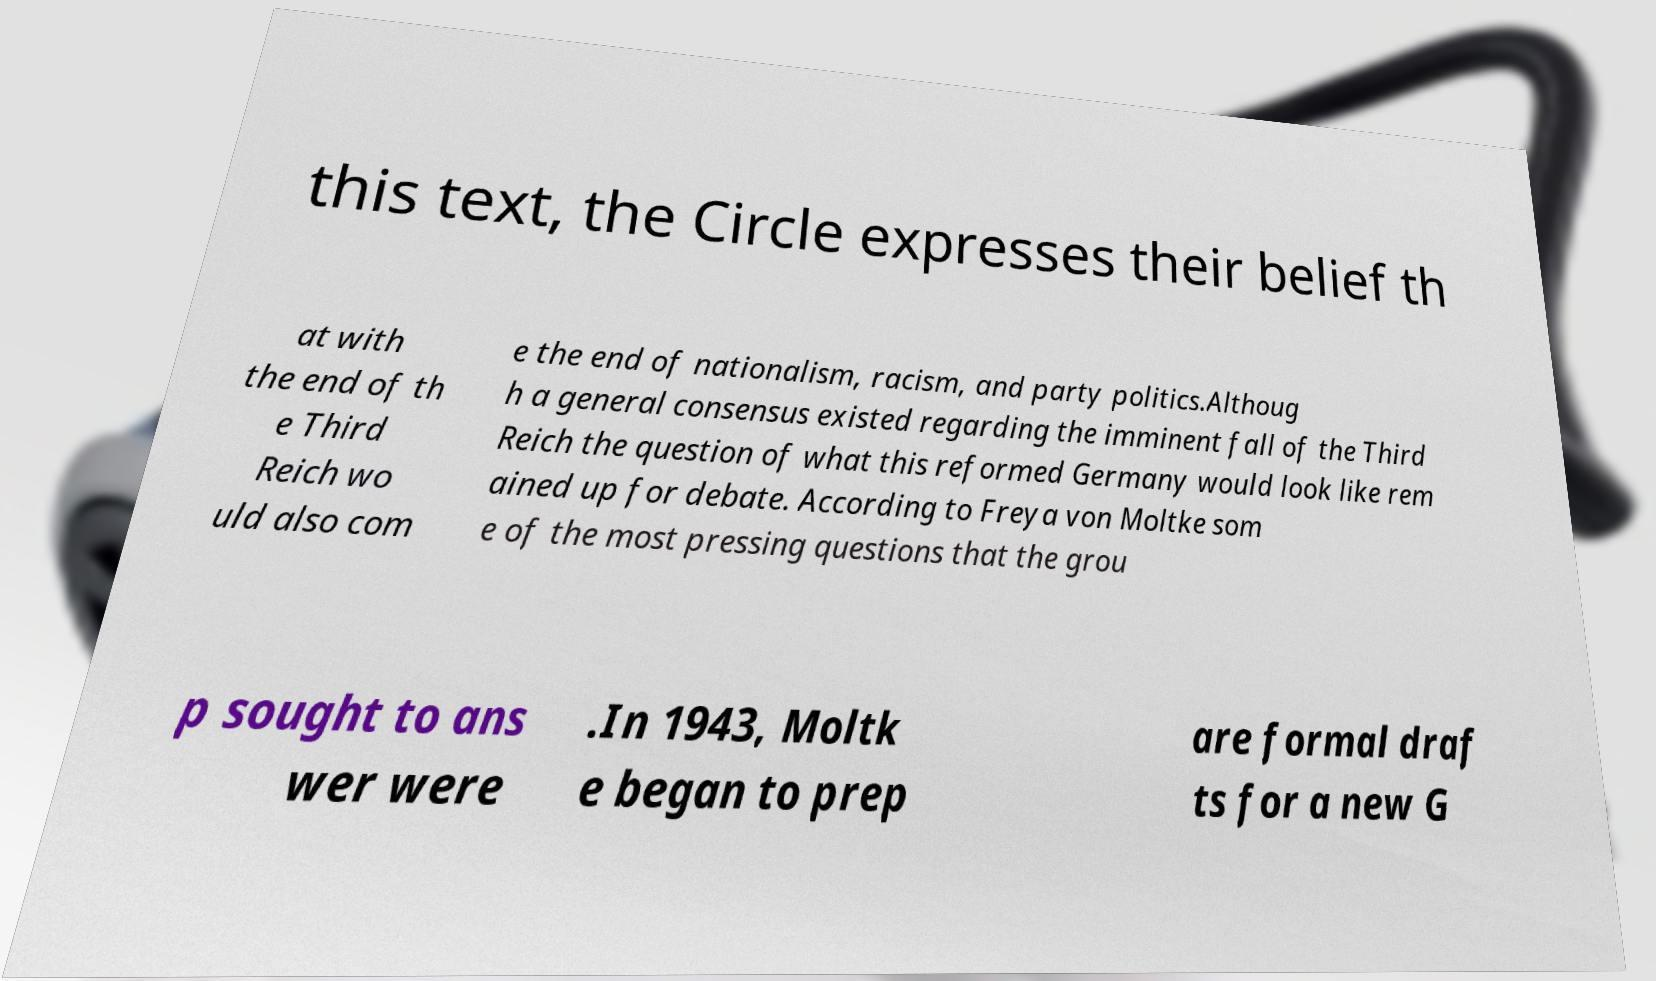Please read and relay the text visible in this image. What does it say? this text, the Circle expresses their belief th at with the end of th e Third Reich wo uld also com e the end of nationalism, racism, and party politics.Althoug h a general consensus existed regarding the imminent fall of the Third Reich the question of what this reformed Germany would look like rem ained up for debate. According to Freya von Moltke som e of the most pressing questions that the grou p sought to ans wer were .In 1943, Moltk e began to prep are formal draf ts for a new G 